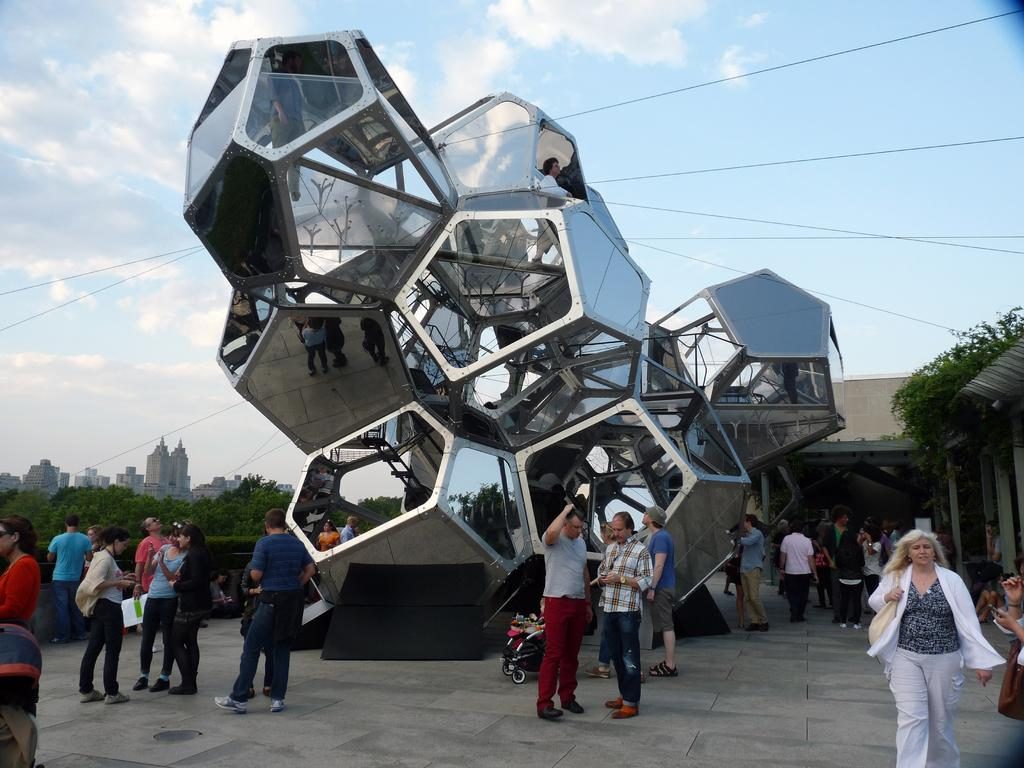How many people are in the image? There is a group of people in the image. What is the position of the people in the image? The people are standing on the ground. What object related to children can be seen in the image? There is a stroller in the image. What type of natural elements are present in the image? There are trees in the image. What type of man-made structures can be seen in the image? There are buildings in the image. What is visible in the background of the image? The sky with clouds is visible in the background of the image. How many sisters are in the image? There is no mention of sisters in the image, so we cannot determine the number of sisters present. 